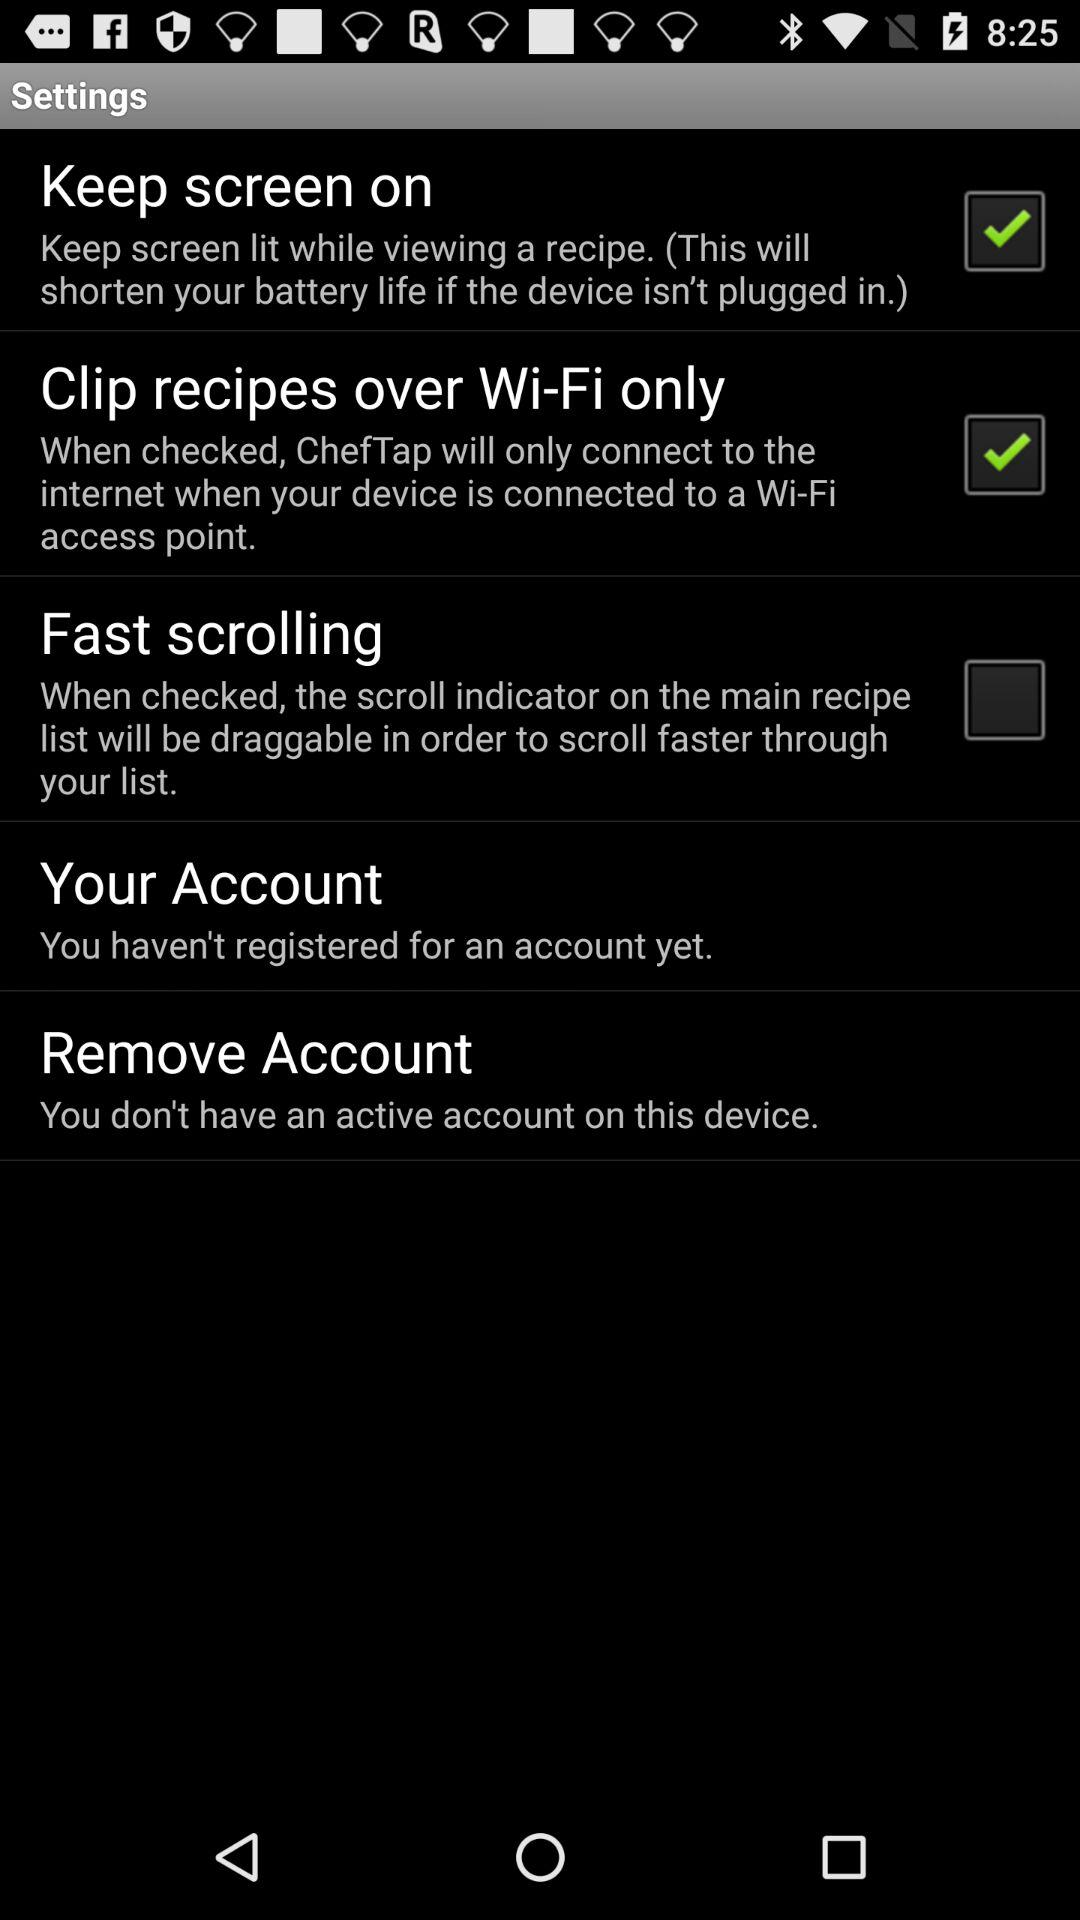What is the status of the "Clip recipes over Wi-Fi only"? The status is on. 